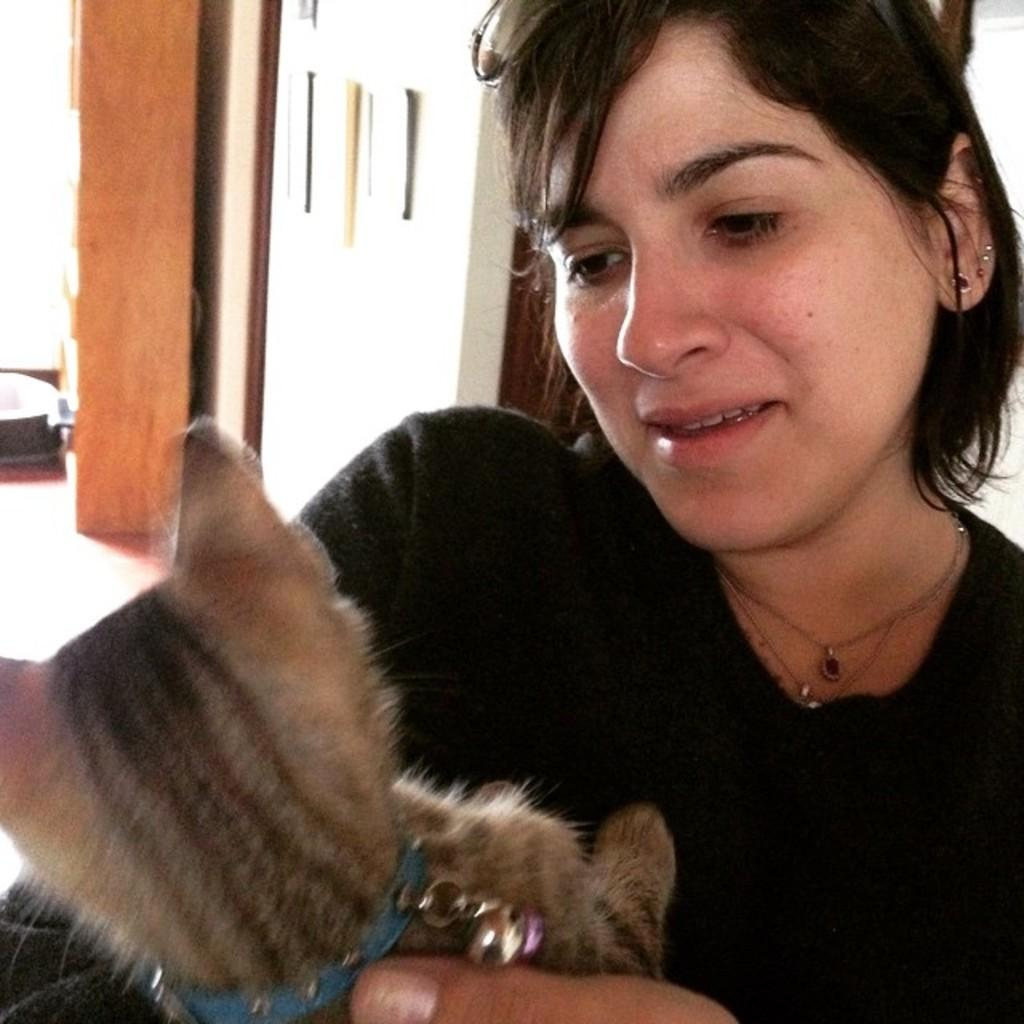What is the person in the image doing? The person is sitting and holding a cat in the image. What is the person's focus in the image? The person is looking at the cat in the image. What can be seen in the background of the image? There is a door and a wall in the backdrop of the image. What type of fowl can be seen sitting on the person's shoulder in the image? There is no fowl present on the person's shoulder in the image. What is the person using to light the cat in the image? The person is not using any matches or lighting the cat in the image; they are simply holding and looking at the cat. 